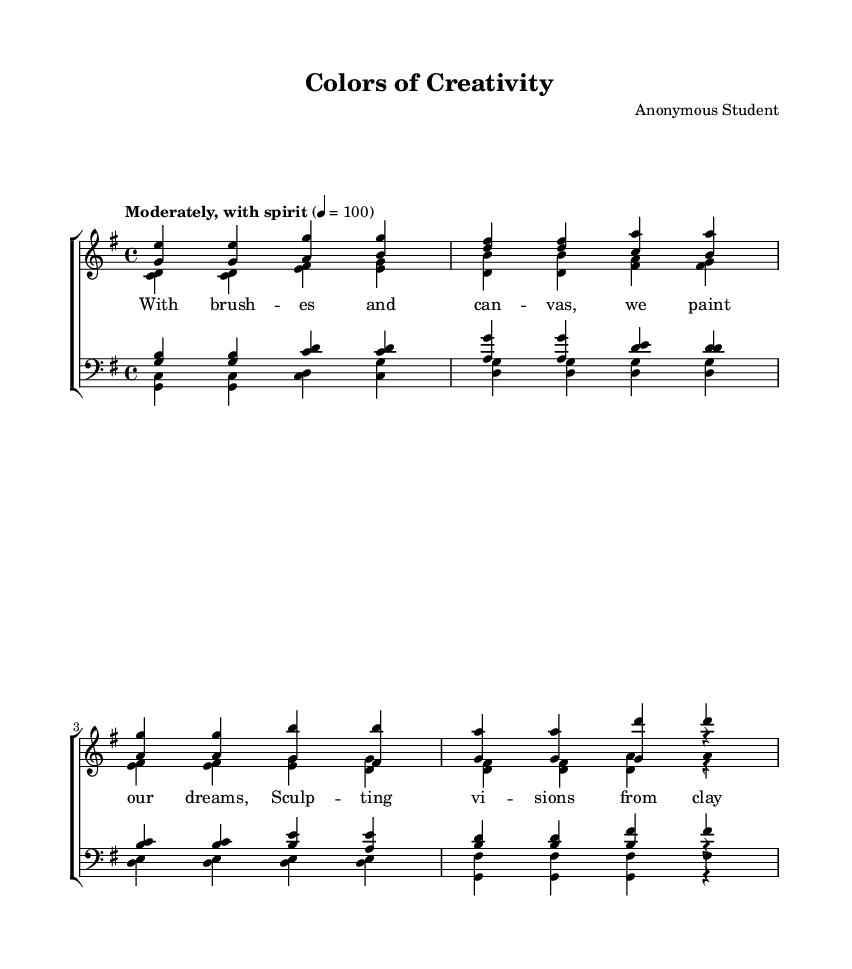What is the key signature of this music? The key signature is G major, which has one sharp (F#). This can be identified from the key signature indication at the beginning of the staff.
Answer: G major What is the time signature of this piece? The time signature is 4/4, which indicates there are four beats in each measure and a quarter note gets one beat. This is found at the beginning of the score.
Answer: 4/4 What is the tempo marking for this piece? The tempo marking is "Moderately, with spirit" and the specified BPM (beats per minute) is 100, noted next to the global settings of the score.
Answer: Moderately, with spirit 100 How many measures are in the soprano verse? The soprano verse contains 4 measures, which can be counted from the notation provided for the soprano part in the verse section.
Answer: 4 Which voices are included in the choir arrangement? The choir arrangement includes sopranos, altos, tenors, and basses, as indicated on the staff labels within the score.
Answer: Soprano, Alto, Tenor, Bass What is the main theme expressed in the chorus lyrics? The main theme expressed in the chorus lyrics is about celebrating art in all its forms, as conveyed by the phrases urging voices to rise and joyful noise.
Answer: Celebrating art How does the tenor chorus end? The tenor chorus ends on a sustained note "b" followed by a rest, indicated at the conclusion of the tenor chorus section.
Answer: b r 